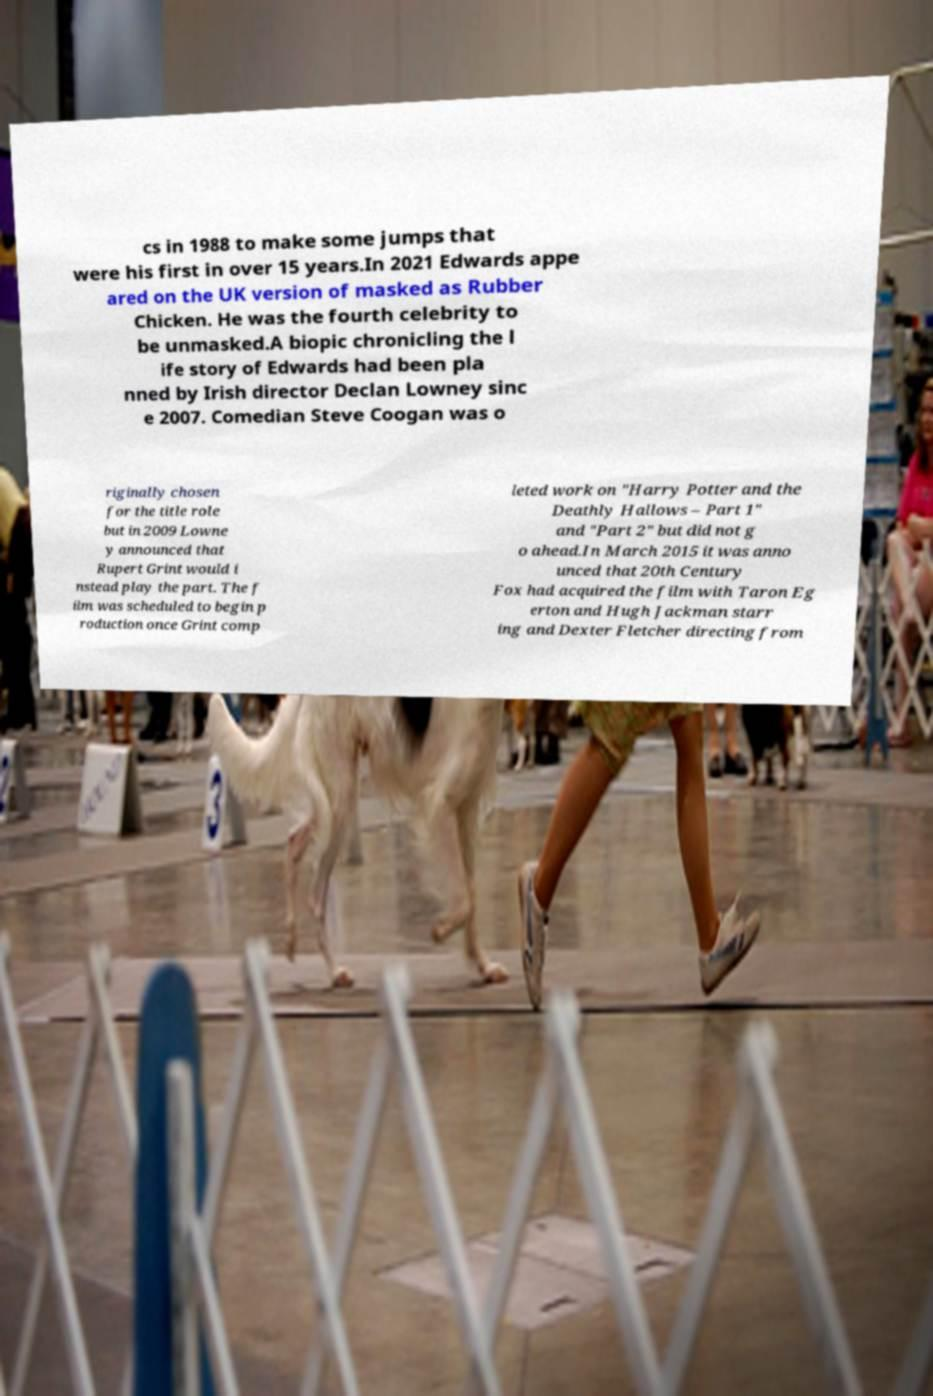Could you extract and type out the text from this image? cs in 1988 to make some jumps that were his first in over 15 years.In 2021 Edwards appe ared on the UK version of masked as Rubber Chicken. He was the fourth celebrity to be unmasked.A biopic chronicling the l ife story of Edwards had been pla nned by Irish director Declan Lowney sinc e 2007. Comedian Steve Coogan was o riginally chosen for the title role but in 2009 Lowne y announced that Rupert Grint would i nstead play the part. The f ilm was scheduled to begin p roduction once Grint comp leted work on "Harry Potter and the Deathly Hallows – Part 1" and "Part 2" but did not g o ahead.In March 2015 it was anno unced that 20th Century Fox had acquired the film with Taron Eg erton and Hugh Jackman starr ing and Dexter Fletcher directing from 